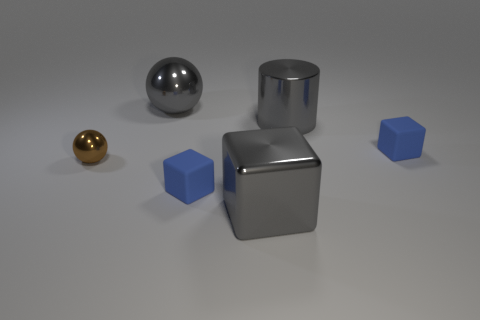What is the cylinder made of?
Your response must be concise. Metal. How many objects are either gray shiny blocks or brown metallic balls?
Your answer should be compact. 2. There is a shiny ball that is in front of the large ball; is its size the same as the blue rubber thing left of the big gray metal block?
Provide a short and direct response. Yes. What number of other things are the same size as the brown metallic sphere?
Keep it short and to the point. 2. What number of things are gray things that are on the left side of the large gray metal cylinder or tiny blue rubber blocks on the left side of the gray cylinder?
Provide a short and direct response. 3. Is the material of the cylinder the same as the small block right of the gray metallic cylinder?
Ensure brevity in your answer.  No. What number of other things are there of the same shape as the tiny brown object?
Your answer should be very brief. 1. The brown thing on the left side of the rubber cube in front of the tiny matte object that is to the right of the big block is made of what material?
Your answer should be compact. Metal. Are there an equal number of big shiny blocks in front of the gray cube and gray shiny cylinders?
Ensure brevity in your answer.  No. Do the large thing behind the gray cylinder and the small block on the right side of the gray metal cube have the same material?
Your answer should be compact. No. 